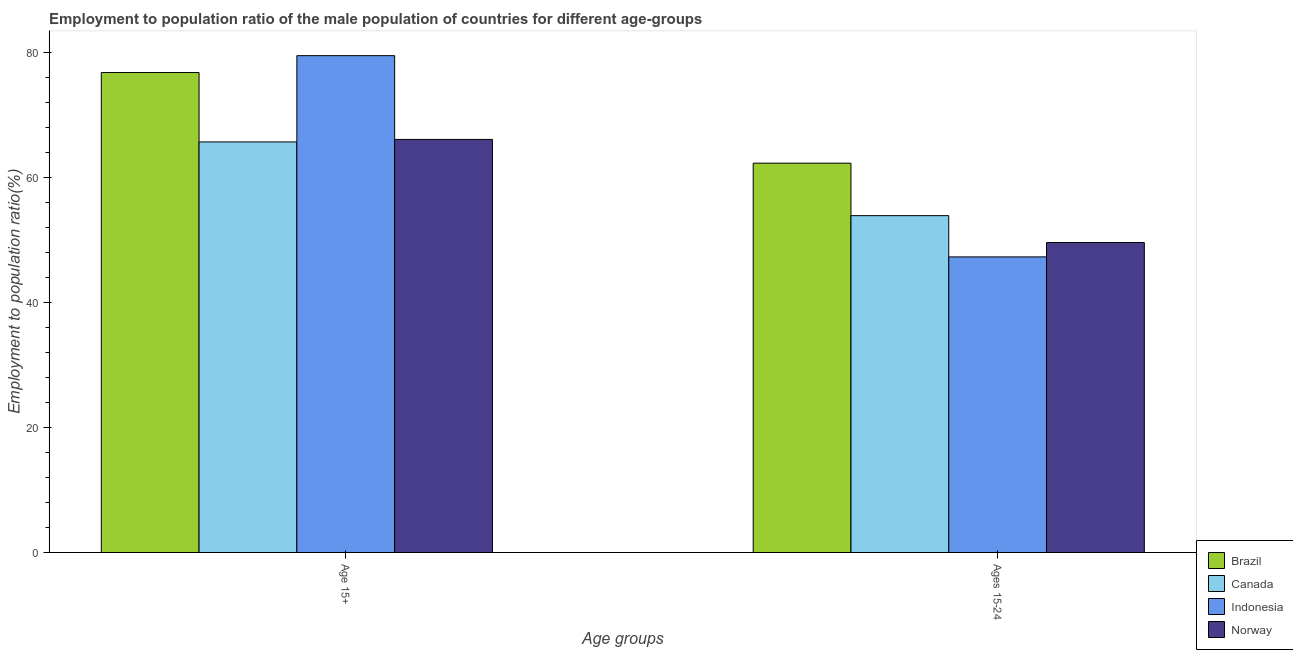How many groups of bars are there?
Keep it short and to the point. 2. Are the number of bars per tick equal to the number of legend labels?
Offer a terse response. Yes. Are the number of bars on each tick of the X-axis equal?
Provide a succinct answer. Yes. How many bars are there on the 1st tick from the left?
Your answer should be very brief. 4. How many bars are there on the 2nd tick from the right?
Your response must be concise. 4. What is the label of the 2nd group of bars from the left?
Keep it short and to the point. Ages 15-24. What is the employment to population ratio(age 15-24) in Indonesia?
Your answer should be very brief. 47.3. Across all countries, what is the maximum employment to population ratio(age 15+)?
Offer a very short reply. 79.5. Across all countries, what is the minimum employment to population ratio(age 15+)?
Offer a very short reply. 65.7. In which country was the employment to population ratio(age 15+) maximum?
Provide a succinct answer. Indonesia. In which country was the employment to population ratio(age 15-24) minimum?
Your answer should be compact. Indonesia. What is the total employment to population ratio(age 15+) in the graph?
Make the answer very short. 288.1. What is the difference between the employment to population ratio(age 15+) in Canada and that in Indonesia?
Your response must be concise. -13.8. What is the difference between the employment to population ratio(age 15+) in Indonesia and the employment to population ratio(age 15-24) in Brazil?
Offer a terse response. 17.2. What is the average employment to population ratio(age 15+) per country?
Your answer should be compact. 72.02. What is the difference between the employment to population ratio(age 15+) and employment to population ratio(age 15-24) in Canada?
Your answer should be very brief. 11.8. What is the ratio of the employment to population ratio(age 15+) in Norway to that in Indonesia?
Your answer should be compact. 0.83. In how many countries, is the employment to population ratio(age 15-24) greater than the average employment to population ratio(age 15-24) taken over all countries?
Your answer should be very brief. 2. Are all the bars in the graph horizontal?
Ensure brevity in your answer.  No. How many countries are there in the graph?
Provide a succinct answer. 4. What is the difference between two consecutive major ticks on the Y-axis?
Your answer should be very brief. 20. Are the values on the major ticks of Y-axis written in scientific E-notation?
Provide a short and direct response. No. Does the graph contain grids?
Offer a terse response. No. Where does the legend appear in the graph?
Your response must be concise. Bottom right. How many legend labels are there?
Your answer should be very brief. 4. How are the legend labels stacked?
Your answer should be compact. Vertical. What is the title of the graph?
Keep it short and to the point. Employment to population ratio of the male population of countries for different age-groups. What is the label or title of the X-axis?
Make the answer very short. Age groups. What is the label or title of the Y-axis?
Provide a short and direct response. Employment to population ratio(%). What is the Employment to population ratio(%) of Brazil in Age 15+?
Your answer should be compact. 76.8. What is the Employment to population ratio(%) of Canada in Age 15+?
Provide a short and direct response. 65.7. What is the Employment to population ratio(%) in Indonesia in Age 15+?
Your response must be concise. 79.5. What is the Employment to population ratio(%) in Norway in Age 15+?
Offer a very short reply. 66.1. What is the Employment to population ratio(%) of Brazil in Ages 15-24?
Your response must be concise. 62.3. What is the Employment to population ratio(%) of Canada in Ages 15-24?
Your answer should be very brief. 53.9. What is the Employment to population ratio(%) in Indonesia in Ages 15-24?
Your answer should be compact. 47.3. What is the Employment to population ratio(%) in Norway in Ages 15-24?
Ensure brevity in your answer.  49.6. Across all Age groups, what is the maximum Employment to population ratio(%) of Brazil?
Your response must be concise. 76.8. Across all Age groups, what is the maximum Employment to population ratio(%) of Canada?
Your answer should be very brief. 65.7. Across all Age groups, what is the maximum Employment to population ratio(%) in Indonesia?
Give a very brief answer. 79.5. Across all Age groups, what is the maximum Employment to population ratio(%) in Norway?
Your answer should be compact. 66.1. Across all Age groups, what is the minimum Employment to population ratio(%) of Brazil?
Give a very brief answer. 62.3. Across all Age groups, what is the minimum Employment to population ratio(%) in Canada?
Provide a short and direct response. 53.9. Across all Age groups, what is the minimum Employment to population ratio(%) in Indonesia?
Make the answer very short. 47.3. Across all Age groups, what is the minimum Employment to population ratio(%) of Norway?
Give a very brief answer. 49.6. What is the total Employment to population ratio(%) of Brazil in the graph?
Provide a succinct answer. 139.1. What is the total Employment to population ratio(%) in Canada in the graph?
Your response must be concise. 119.6. What is the total Employment to population ratio(%) in Indonesia in the graph?
Make the answer very short. 126.8. What is the total Employment to population ratio(%) in Norway in the graph?
Give a very brief answer. 115.7. What is the difference between the Employment to population ratio(%) of Brazil in Age 15+ and that in Ages 15-24?
Offer a very short reply. 14.5. What is the difference between the Employment to population ratio(%) of Canada in Age 15+ and that in Ages 15-24?
Keep it short and to the point. 11.8. What is the difference between the Employment to population ratio(%) in Indonesia in Age 15+ and that in Ages 15-24?
Provide a succinct answer. 32.2. What is the difference between the Employment to population ratio(%) in Brazil in Age 15+ and the Employment to population ratio(%) in Canada in Ages 15-24?
Provide a succinct answer. 22.9. What is the difference between the Employment to population ratio(%) in Brazil in Age 15+ and the Employment to population ratio(%) in Indonesia in Ages 15-24?
Your answer should be very brief. 29.5. What is the difference between the Employment to population ratio(%) of Brazil in Age 15+ and the Employment to population ratio(%) of Norway in Ages 15-24?
Make the answer very short. 27.2. What is the difference between the Employment to population ratio(%) of Canada in Age 15+ and the Employment to population ratio(%) of Norway in Ages 15-24?
Keep it short and to the point. 16.1. What is the difference between the Employment to population ratio(%) in Indonesia in Age 15+ and the Employment to population ratio(%) in Norway in Ages 15-24?
Make the answer very short. 29.9. What is the average Employment to population ratio(%) of Brazil per Age groups?
Give a very brief answer. 69.55. What is the average Employment to population ratio(%) in Canada per Age groups?
Offer a very short reply. 59.8. What is the average Employment to population ratio(%) of Indonesia per Age groups?
Ensure brevity in your answer.  63.4. What is the average Employment to population ratio(%) of Norway per Age groups?
Provide a short and direct response. 57.85. What is the difference between the Employment to population ratio(%) in Brazil and Employment to population ratio(%) in Norway in Age 15+?
Provide a succinct answer. 10.7. What is the difference between the Employment to population ratio(%) in Canada and Employment to population ratio(%) in Indonesia in Ages 15-24?
Provide a succinct answer. 6.6. What is the difference between the Employment to population ratio(%) of Indonesia and Employment to population ratio(%) of Norway in Ages 15-24?
Offer a terse response. -2.3. What is the ratio of the Employment to population ratio(%) in Brazil in Age 15+ to that in Ages 15-24?
Make the answer very short. 1.23. What is the ratio of the Employment to population ratio(%) in Canada in Age 15+ to that in Ages 15-24?
Keep it short and to the point. 1.22. What is the ratio of the Employment to population ratio(%) in Indonesia in Age 15+ to that in Ages 15-24?
Offer a very short reply. 1.68. What is the ratio of the Employment to population ratio(%) of Norway in Age 15+ to that in Ages 15-24?
Offer a very short reply. 1.33. What is the difference between the highest and the second highest Employment to population ratio(%) in Brazil?
Give a very brief answer. 14.5. What is the difference between the highest and the second highest Employment to population ratio(%) of Indonesia?
Provide a succinct answer. 32.2. What is the difference between the highest and the second highest Employment to population ratio(%) of Norway?
Make the answer very short. 16.5. What is the difference between the highest and the lowest Employment to population ratio(%) of Canada?
Give a very brief answer. 11.8. What is the difference between the highest and the lowest Employment to population ratio(%) in Indonesia?
Provide a succinct answer. 32.2. 